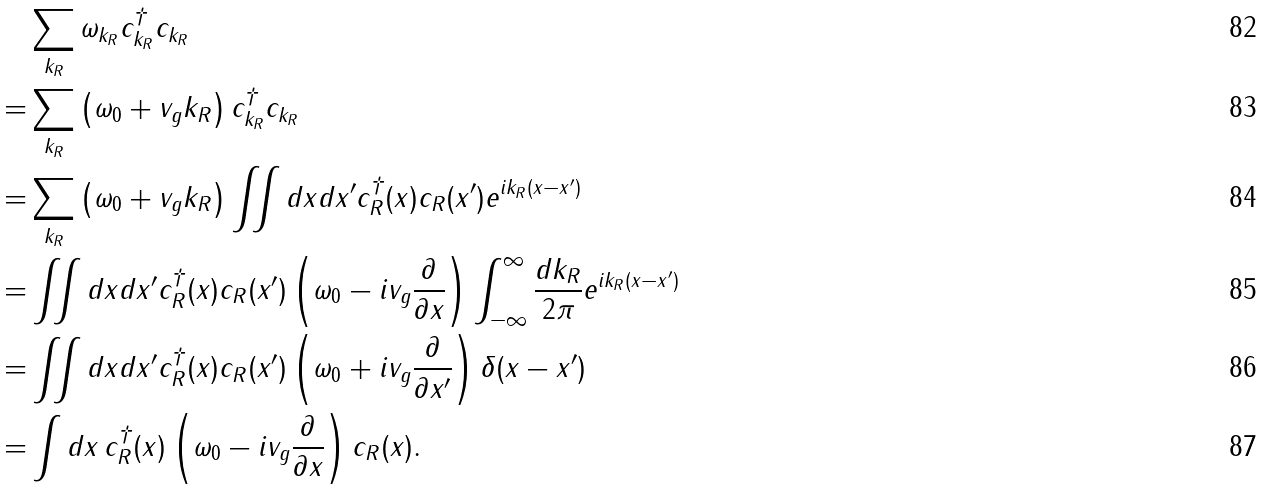<formula> <loc_0><loc_0><loc_500><loc_500>& \sum _ { k _ { R } } \omega _ { k _ { R } } c _ { k _ { R } } ^ { \dagger } c _ { k _ { R } } \\ = & \sum _ { k _ { R } } \left ( \omega _ { 0 } + v _ { g } k _ { R } \right ) c _ { k _ { R } } ^ { \dagger } c _ { k _ { R } } \\ = & \sum _ { k _ { R } } \left ( \omega _ { 0 } + v _ { g } k _ { R } \right ) \iint d x d x ^ { \prime } c _ { R } ^ { \dagger } ( x ) c _ { R } ( x ^ { \prime } ) e ^ { i k _ { R } ( x - x ^ { \prime } ) } \\ = & \iint d x d x ^ { \prime } c _ { R } ^ { \dagger } ( x ) c _ { R } ( x ^ { \prime } ) \left ( \omega _ { 0 } - i v _ { g } \frac { \partial } { \partial x } \right ) \int _ { - \infty } ^ { \infty } \frac { d k _ { R } } { 2 \pi } e ^ { i k _ { R } ( x - x ^ { \prime } ) } \\ = & \iint d x d x ^ { \prime } c _ { R } ^ { \dagger } ( x ) c _ { R } ( x ^ { \prime } ) \left ( \omega _ { 0 } + i v _ { g } \frac { \partial } { \partial x ^ { \prime } } \right ) \delta ( x - x ^ { \prime } ) \\ = & \int d x \, c _ { R } ^ { \dagger } ( x ) \left ( \omega _ { 0 } - i v _ { g } \frac { \partial } { \partial x } \right ) c _ { R } ( x ) .</formula> 